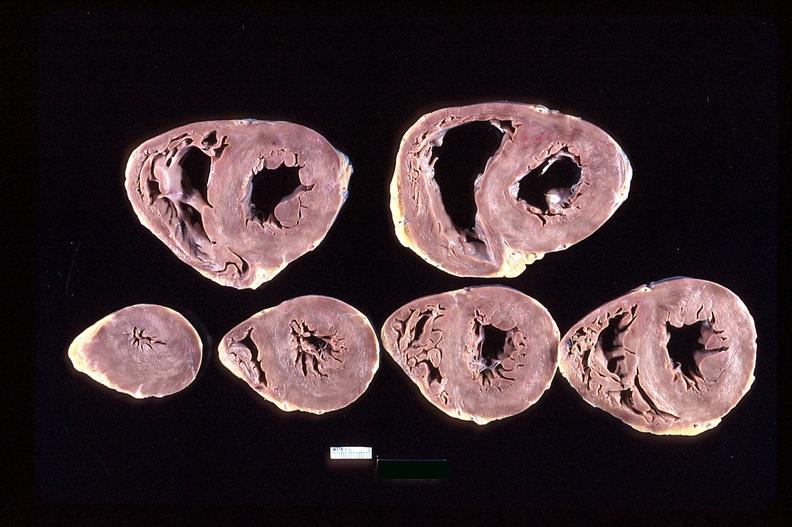does this image show heart slices, acute posterior myocardial infarction in patient with hypertension?
Answer the question using a single word or phrase. Yes 